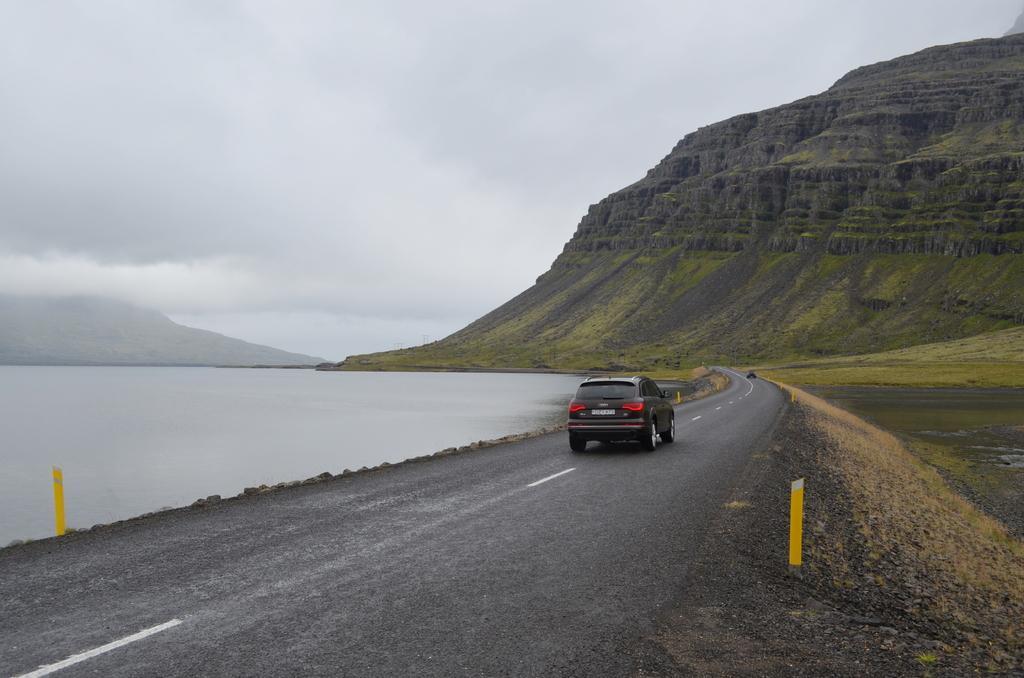Could you give a brief overview of what you see in this image? In this image we can see a black color car is moving on the road. Here we can see water, grassland, hills and cloudy sky in the background. 